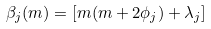<formula> <loc_0><loc_0><loc_500><loc_500>\beta _ { j } ( m ) = [ m ( m + 2 \phi _ { j } ) + \lambda _ { j } ]</formula> 